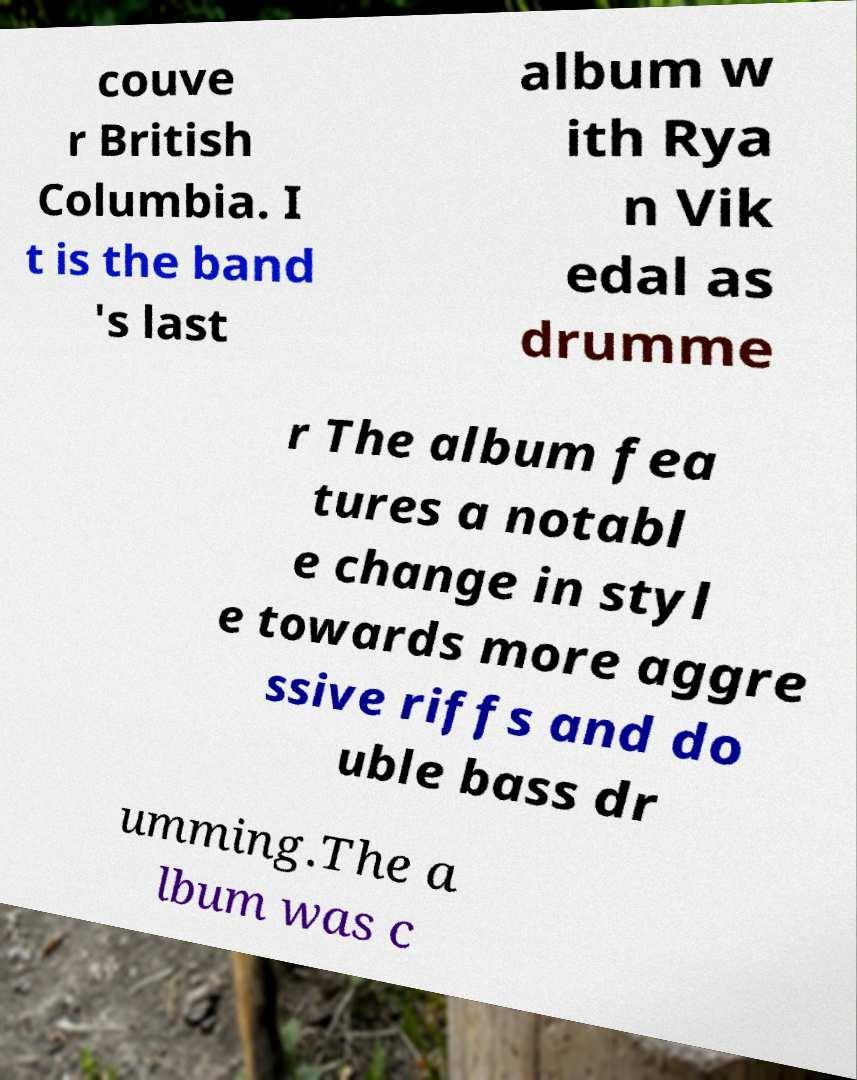Could you assist in decoding the text presented in this image and type it out clearly? couve r British Columbia. I t is the band 's last album w ith Rya n Vik edal as drumme r The album fea tures a notabl e change in styl e towards more aggre ssive riffs and do uble bass dr umming.The a lbum was c 